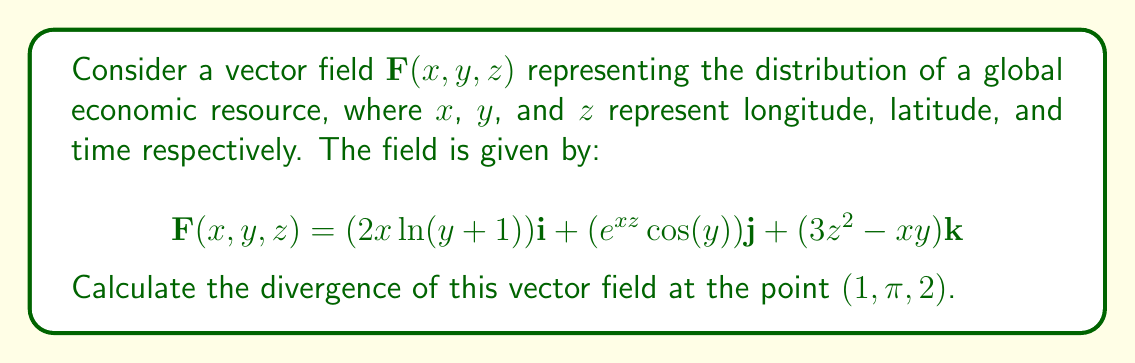Show me your answer to this math problem. To solve this problem, we need to follow these steps:

1) Recall that the divergence of a vector field $\mathbf{F}(x, y, z) = P\mathbf{i} + Q\mathbf{j} + R\mathbf{k}$ is given by:

   $$\text{div}\mathbf{F} = \nabla \cdot \mathbf{F} = \frac{\partial P}{\partial x} + \frac{\partial Q}{\partial y} + \frac{\partial R}{\partial z}$$

2) In our case:
   $P(x,y,z) = 2x\ln(y+1)$
   $Q(x,y,z) = e^{xz}\cos(y)$
   $R(x,y,z) = 3z^2 - xy$

3) Let's calculate each partial derivative:

   $\frac{\partial P}{\partial x} = 2\ln(y+1)$

   $\frac{\partial Q}{\partial y} = -e^{xz}\sin(y)$

   $\frac{\partial R}{\partial z} = 6z$

4) Now, we sum these partial derivatives:

   $$\text{div}\mathbf{F} = 2\ln(y+1) - e^{xz}\sin(y) + 6z$$

5) Finally, we evaluate this at the point $(1, \pi, 2)$:

   $$\text{div}\mathbf{F}(1,\pi,2) = 2\ln(\pi+1) - e^{1\cdot2}\sin(\pi) + 6\cdot2$$

6) Simplify:
   $\sin(\pi) = 0$, so the middle term becomes zero.
   
   $$\text{div}\mathbf{F}(1,\pi,2) = 2\ln(\pi+1) + 12$$
Answer: The divergence of the vector field at the point $(1, \pi, 2)$ is:

$$2\ln(\pi+1) + 12$$ 